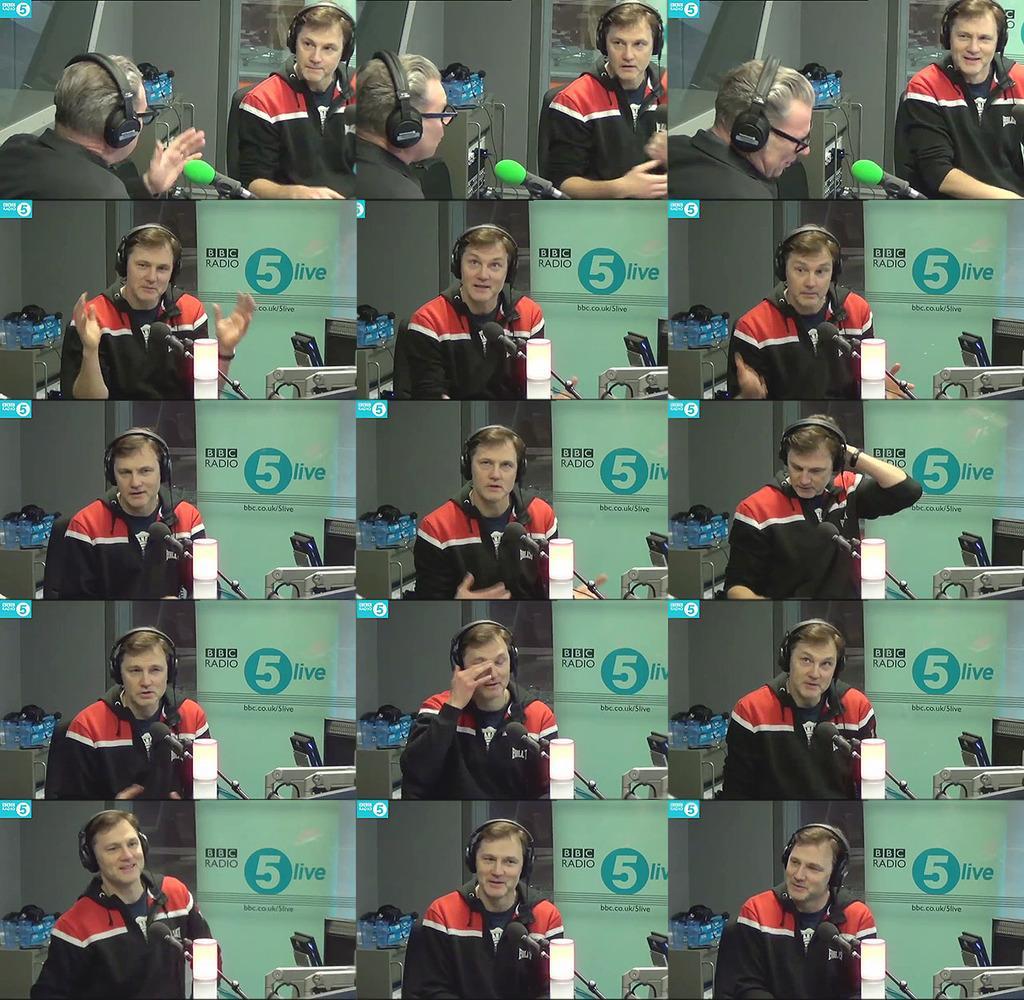Describe this image in one or two sentences. It's a photo collage, in this a man is wearing headset, he wore black color t-shirt. 